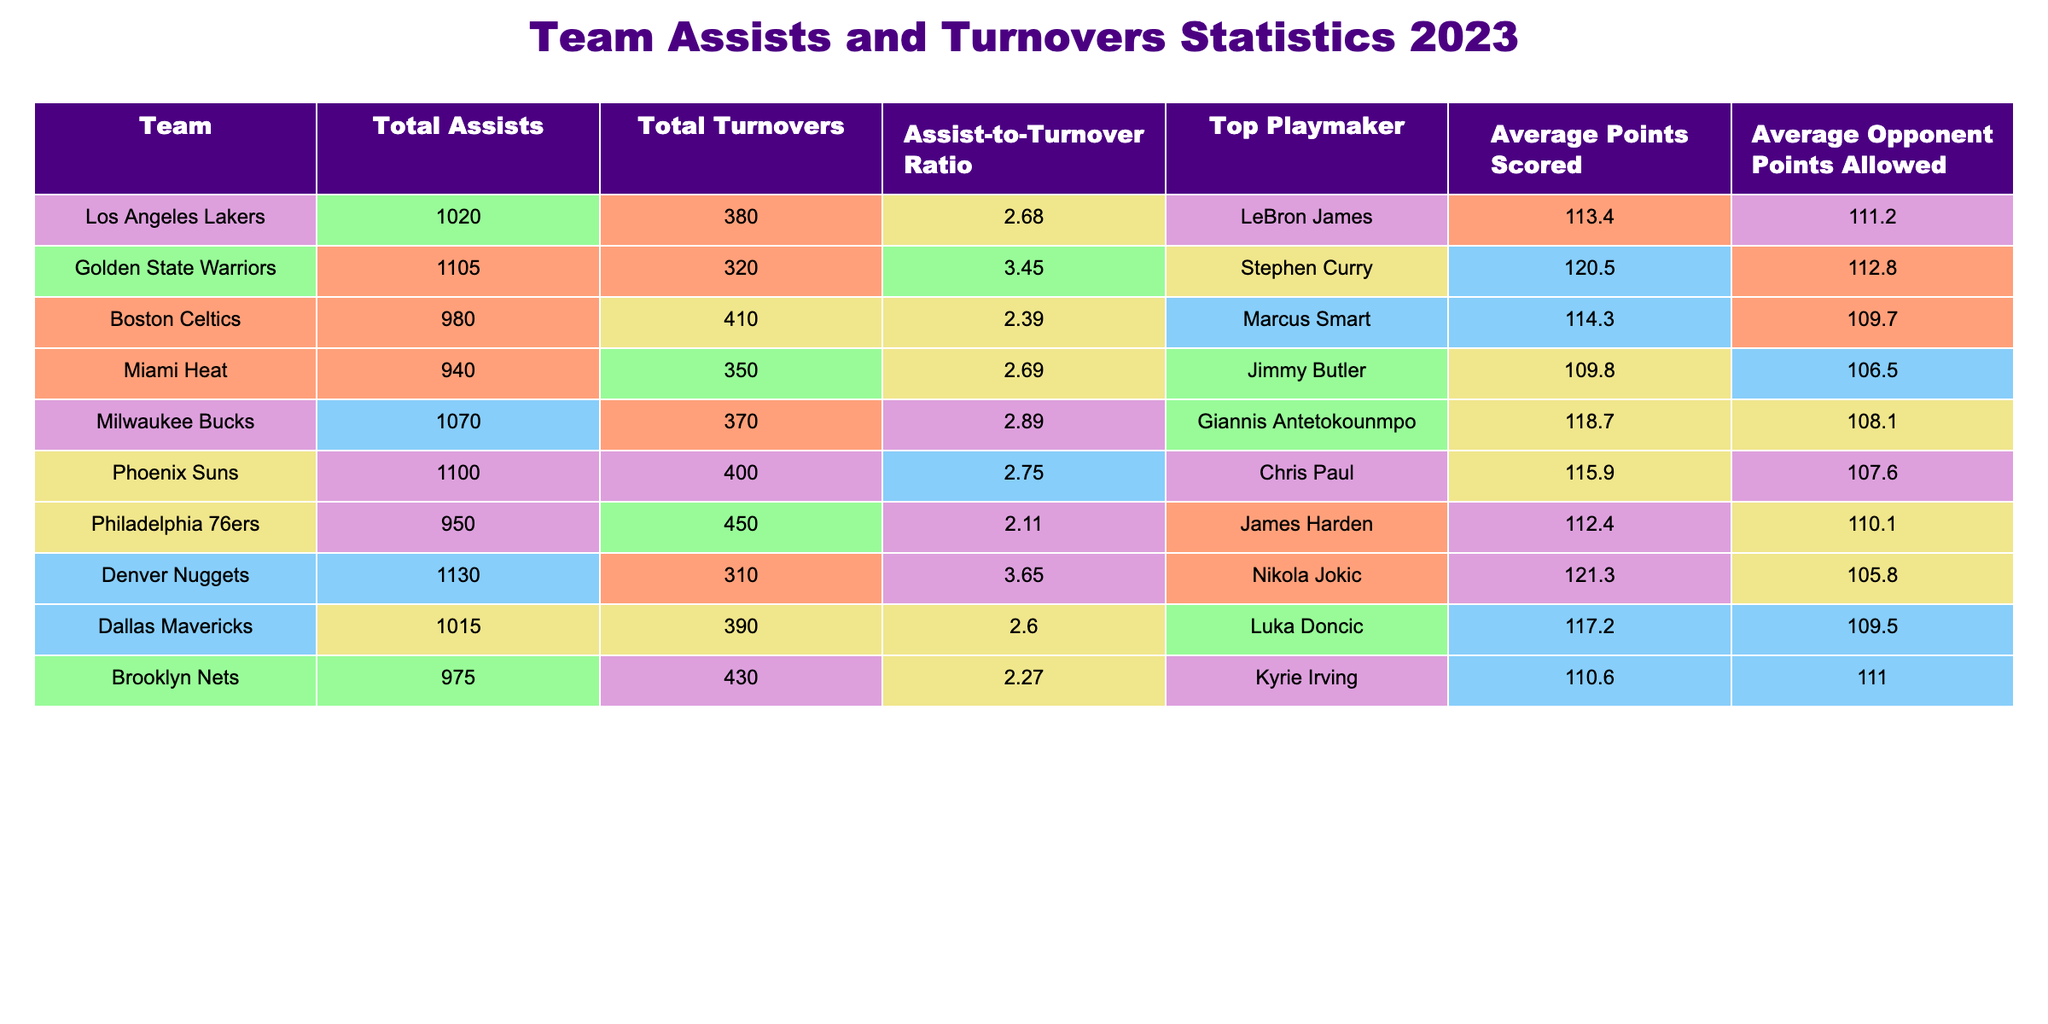What is the team with the highest total assists? Looking at the "Total Assists" column, the Golden State Warriors have the highest value at 1105.
Answer: Golden State Warriors Which team has the lowest assist-to-turnover ratio? The "Assist-to-Turnover Ratio" shows that the Philadelphia 76ers have the lowest ratio at 2.11.
Answer: Philadelphia 76ers How many total assists do the Miami Heat have compared to the Boston Celtics? The Miami Heat have 940 total assists, while the Boston Celtics have 980. This means the Celtics have 40 more assists than the Heat.
Answer: 40 Which team scored the most average points per game? Checking the "Average Points Scored" column, the Denver Nuggets scored the most with an average of 121.3 points per game.
Answer: Denver Nuggets Is it true that the Milwaukee Bucks have more turnovers than the Miami Heat? The Milwaukee Bucks have 370 turnovers while the Miami Heat have 350. Thus, it is true that the Bucks have more turnovers.
Answer: Yes What is the combined total of assists and turnovers for the Los Angeles Lakers? The Lakers have 1020 total assists and 380 turnovers. Adding these gives 1020 + 380 = 1400.
Answer: 1400 Which player is the top playmaker for the team with the second-highest assist-to-turnover ratio? The team with the second-highest ratio is Golden State Warriors (3.45). Their top playmaker is Stephen Curry.
Answer: Stephen Curry What is the difference in average points scored between the highest and lowest scoring teams? The highest average points scored is by the Nuggets (121.3) and the lowest is by the 76ers (112.4). The difference is 121.3 - 112.4 = 8.9.
Answer: 8.9 Which team has the best turnover-to-assist ratio among those displayed? The turnover-to-assist ratio is calculated by taking the inverse of the assist-to-turnover ratio. The team with the lowest ratio is the Denver Nuggets with an assist-to-turnover ratio of 3.65, indicating they make the best use of their assists.
Answer: Denver Nuggets How many assists does the Phoenix Suns have more than the Brooklyn Nets? The Phoenix Suns have 1100 total assists, and the Brooklyn Nets have 975. Thus, the Suns have 1100 - 975 = 125 more assists than the Nets.
Answer: 125 Which team allowed the fewest points on average? The "Average Opponent Points Allowed" column shows that the Denver Nuggets allowed the fewest points, averaging 105.8.
Answer: Denver Nuggets 